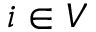Convert formula to latex. <formula><loc_0><loc_0><loc_500><loc_500>i \in V</formula> 